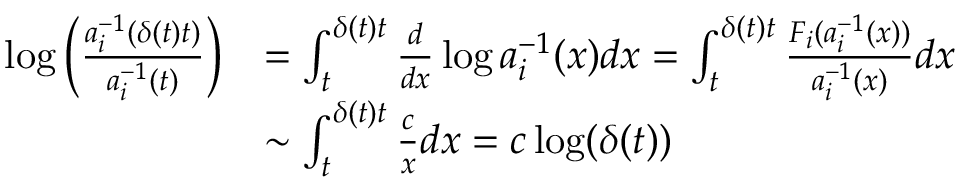<formula> <loc_0><loc_0><loc_500><loc_500>\begin{array} { r l } { \log \left ( \frac { a _ { i } ^ { - 1 } ( \delta ( t ) t ) } { a _ { i } ^ { - 1 } ( t ) } \right ) } & { = \int _ { t } ^ { \delta ( t ) t } \frac { d } { d x } \log a _ { i } ^ { - 1 } ( x ) d x = \int _ { t } ^ { \delta ( t ) t } \frac { F _ { i } ( a _ { i } ^ { - 1 } ( x ) ) } { a _ { i } ^ { - 1 } ( x ) } d x } \\ & { \sim \int _ { t } ^ { \delta ( t ) t } \frac { c } { x } d x = c \log ( \delta ( t ) ) } \end{array}</formula> 